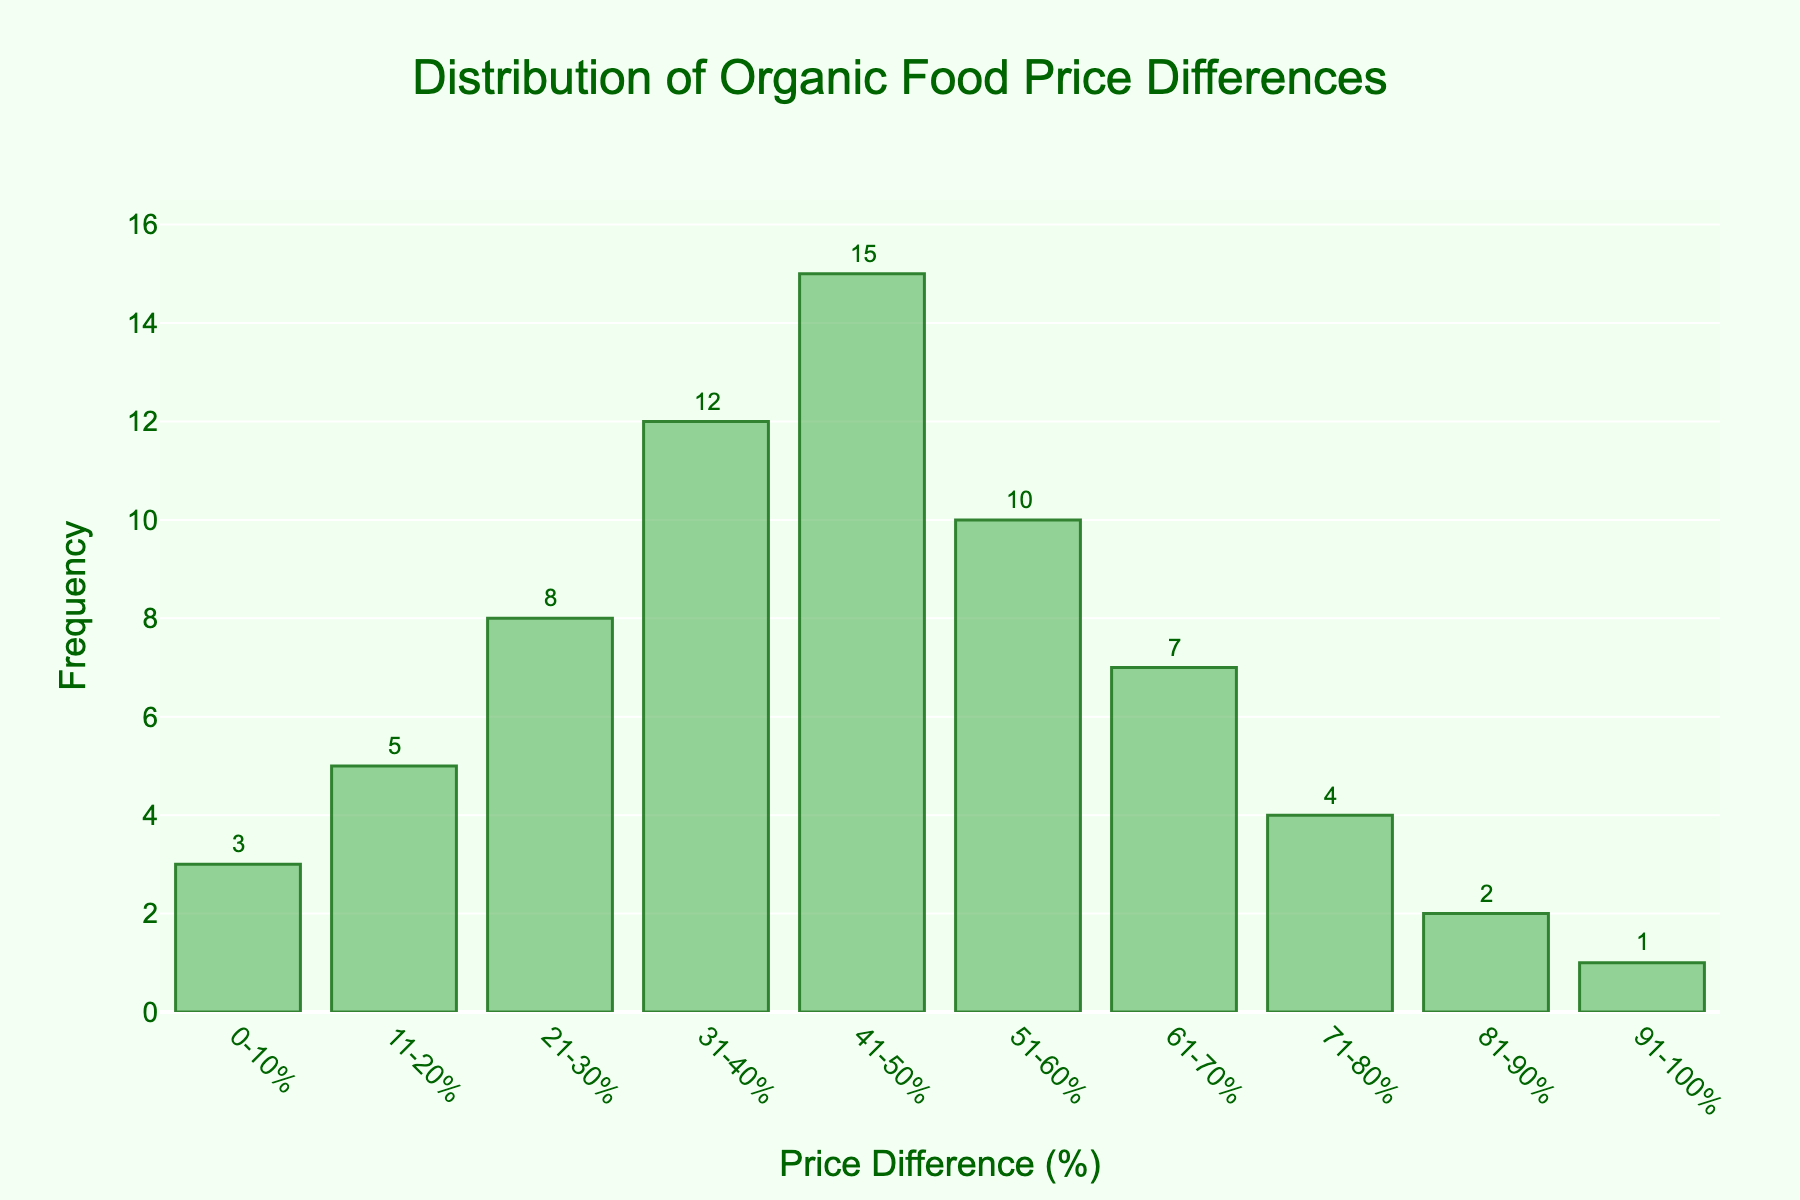What is the title of the histogram? The title is located at the top of the figure. By reading the text, we can see it is about the distribution of price differences for organic foods.
Answer: Distribution of Organic Food Price Differences What is the frequency for the 41-50% price difference range? Locate the bar corresponding to the 41-50% price difference range and check its height. The annotation on the figure also shows the number.
Answer: 15 What's the most frequent price difference range? By comparing the heights of all the bars, the tallest bar represents the most frequent price difference range.
Answer: 41-50% Which price difference range has the lowest frequency? The shortest bar represents the price difference range with the lowest frequency.
Answer: 91-100% How many price difference ranges have a frequency greater than 10? Count the number of bars with heights extending above the 10 frequency mark on the y-axis.
Answer: 3 What's the total frequency for all price difference ranges between 0-40%? To find the total frequency, add the frequencies of the 0-10%, 11-20%, 21-30%, and 31-40% ranges. So, 3 + 5 + 8 + 12 = 28.
Answer: 28 What is the average frequency for all price difference ranges? Add up all the frequencies and divide by the number of ranges. The sum is 3 + 5 + 8 + 12 + 15 + 10 + 7 + 4 + 2 + 1 = 67, and there are 10 ranges. Hence, the average frequency is 67 / 10 = 6.7.
Answer: 6.7 Does the frequency generally increase or decrease as the price difference increases? Observing the general trend of the heights of the bars from left to right, they initially increase and then decrease.
Answer: Increase then decrease Which price difference ranges have a frequency between 5 and 10? Identify the bars whose heights fall between 5 and 10 units on the y-axis. These ranges are 11-20% (5), 21-30% (8), and 51-60% (10).
Answer: 11-20%, 21-30%, 51-60% How much higher is the frequency for the 41-50% range compared to the 0-10% range? Subtract the frequency of the 0-10% range from the frequency of the 41-50% range, i.e., 15 - 3 = 12.
Answer: 12 